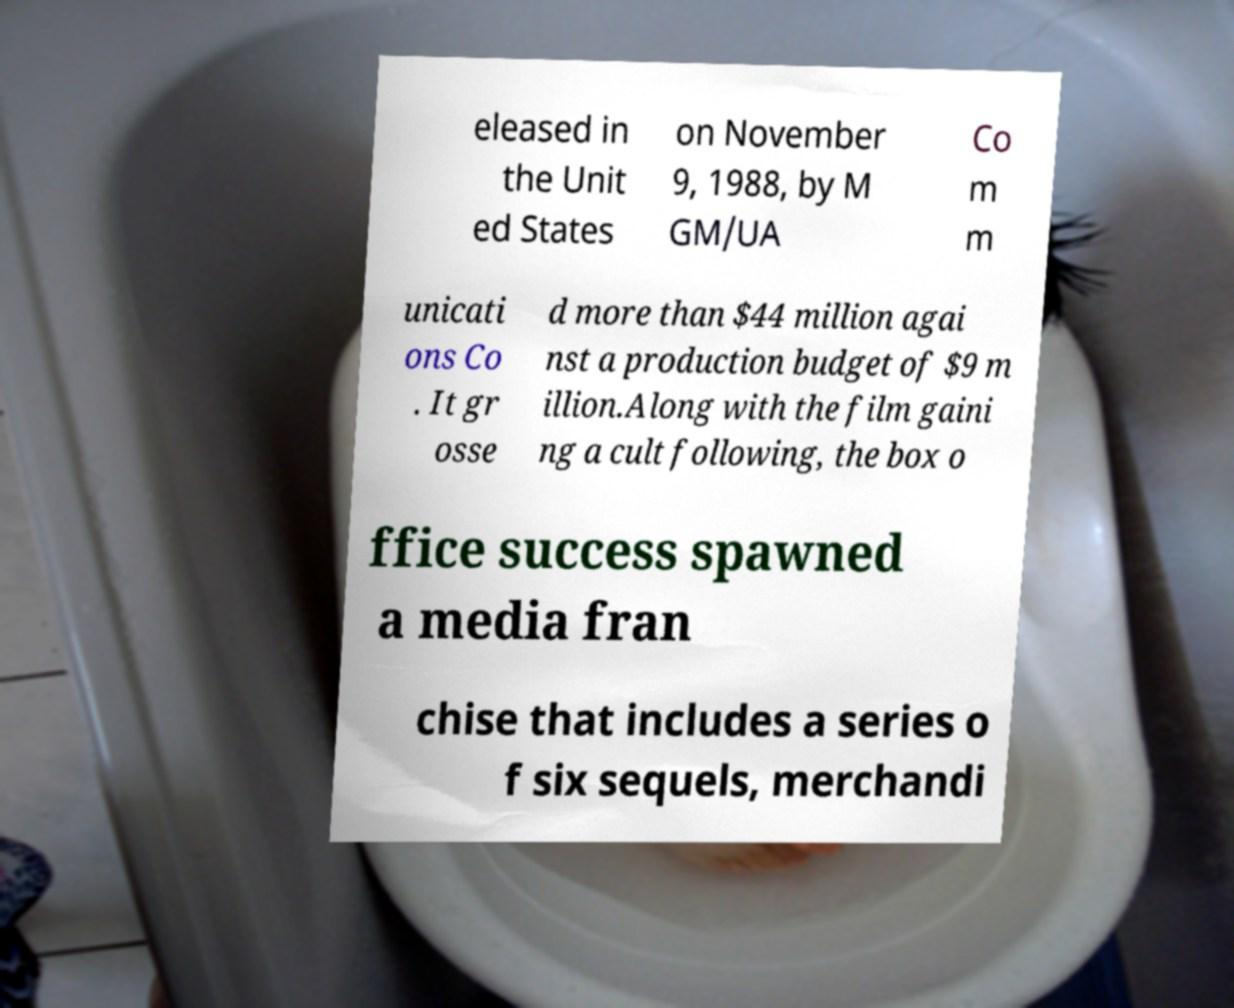For documentation purposes, I need the text within this image transcribed. Could you provide that? eleased in the Unit ed States on November 9, 1988, by M GM/UA Co m m unicati ons Co . It gr osse d more than $44 million agai nst a production budget of $9 m illion.Along with the film gaini ng a cult following, the box o ffice success spawned a media fran chise that includes a series o f six sequels, merchandi 